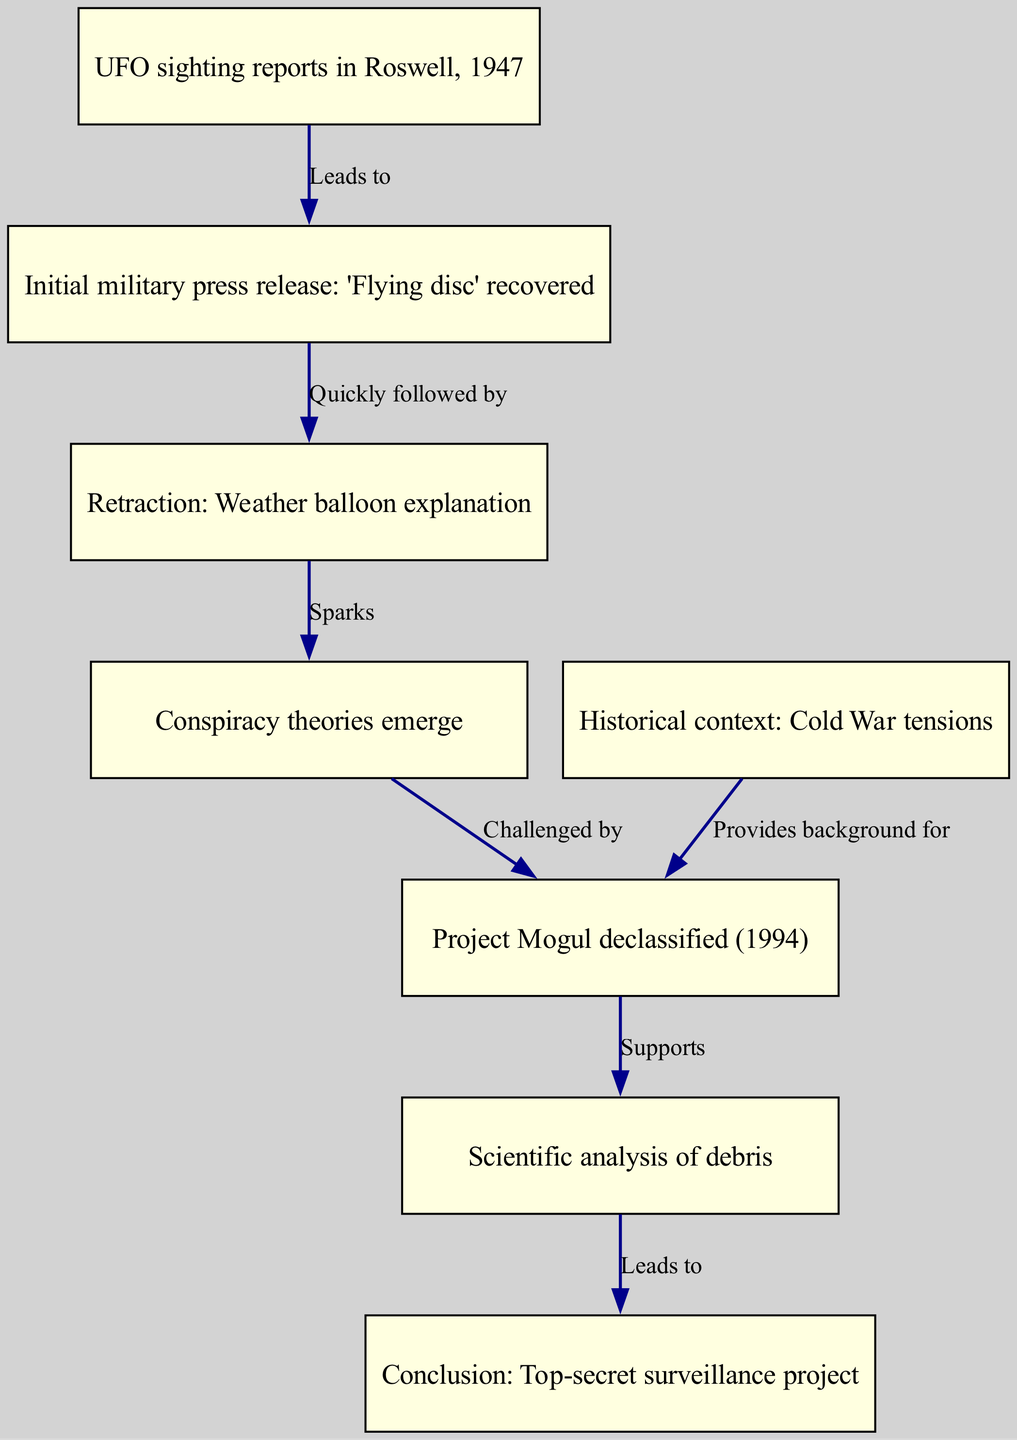What is the title of the first node in the diagram? The first node is labeled "UFO sighting reports in Roswell, 1947," which is provided directly in the text of the diagram.
Answer: UFO sighting reports in Roswell, 1947 How many nodes are there in total? By counting each individual item listed under "nodes" in the data provided, we can determine that there are eight unique entries.
Answer: 8 What does the second node claim to have recovered? The second node states: "Initial military press release: 'Flying disc' recovered," directly reflecting the information presented.
Answer: 'Flying disc' recovered Which node is connected to "Retraction: Weather balloon explanation"? The edge connects directly from the second node, "Initial military press release: 'Flying disc' recovered," to the third node, which contains the retraction information.
Answer: Retraction: Weather balloon explanation What sparked the emergence of conspiracy theories in this pathway? The transition from the "Retraction: Weather balloon explanation" node to the "Conspiracy theories emerge" node indicates that the retraction act sparked the conspiracy theories.
Answer: Sparks What supports the conclusion that the event relates to a top-secret surveillance project? The edge connecting the "Project Mogul declassified (1994)" to "Scientific analysis of debris" ultimately leads to the conclusion node: "Top-secret surveillance project," showing how project declassification supports that conclusion.
Answer: Supports What provides background for the connection to the Project Mogul? The node "Historical context: Cold War tensions" provides necessary background for understanding the context of the Project Mogul within this timeline of events.
Answer: Provides background for How many connections lead from the node "Conspiracy theories emerge"? There is one outgoing edge from the "Conspiracy theories emerge" node leading directly to the "Project Mogul declassified (1994)" node, indicating the singular connection.
Answer: 1 